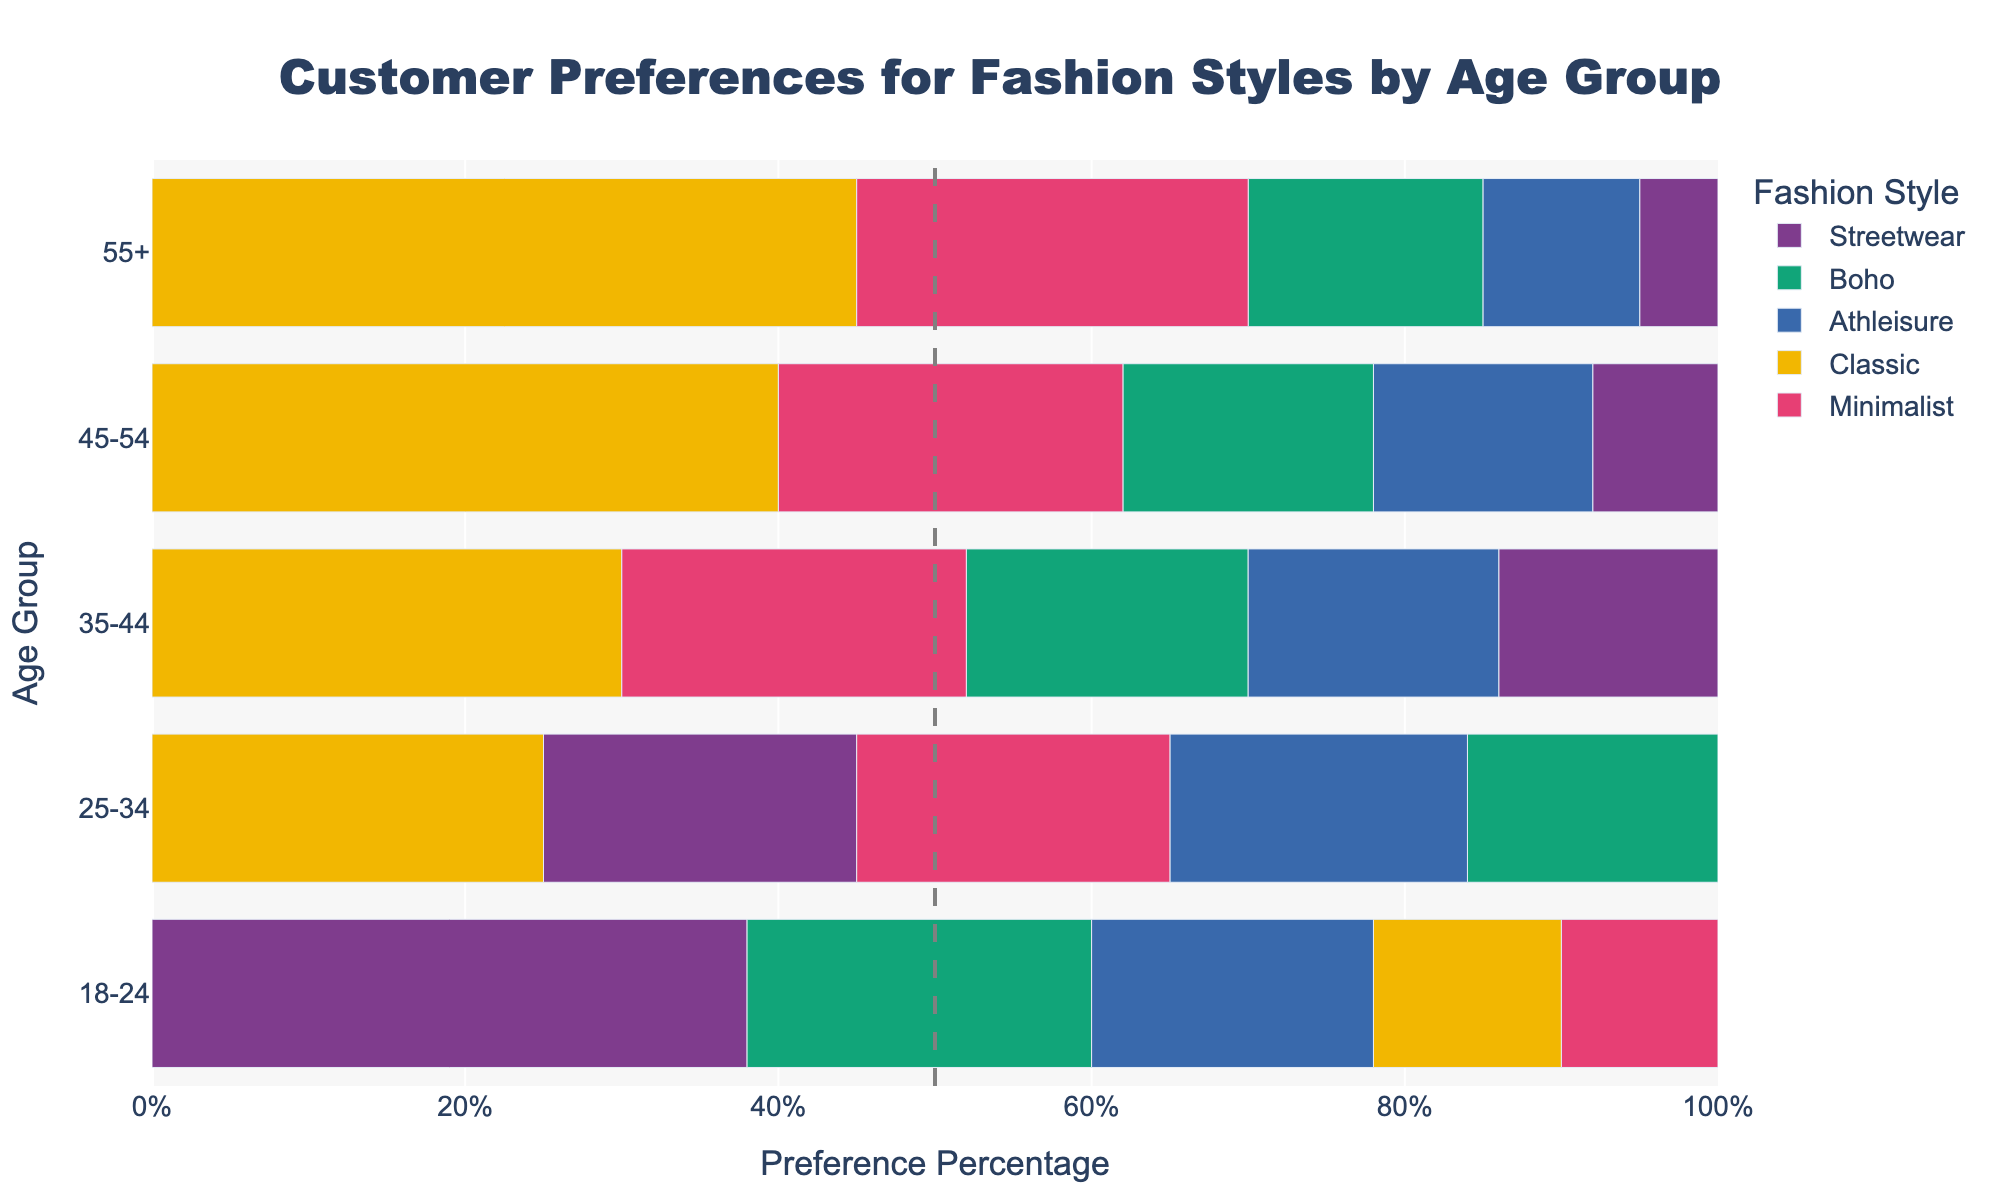Which age group exhibits the highest preference for Classic style? The chart clearly shows that the bar representing the Classic style is longest for the 55+ age group, indicating their strong preference.
Answer: 55+ How does the preference for Streetwear differ between the 18-24 age group and the 55+ age group? By comparing the length of the bars for Streetwear in both age groups, it is visible that it is significantly longer for the 18-24 age group. The preference percentage for Streetwear is 38% for the 18-24 group and 5% for the 55+ group.
Answer: 33% higher for 18-24 Which style is the second most preferred by the 25-34 age group? Observing the length of the bars within the 25-34 age group segment, Classic has the highest preference followed by Minimalist, with the next longer bar.
Answer: Minimalist What is the total preference percentage for all styles combined in the 35-44 age group? Adding up the bars for the 35-44 age group: Classic (30%) + Boho (18%) + Athleisure (16%) + Minimalist (22%) + Streetwear (14%) gives the total preference percentage.
Answer: 100% Which two age groups have an equal preference for the Classic style? Comparing the lengths of the Classic style bars across all age groups, it's noted that the lengths for the 25-34 and 35-44 age groups are equal.
Answer: 25-34 and 35-44 What style has the same preference percentage of 22% in both the 18-24 and 45-54 age groups? By matching the bars with equal lengths for both age groups, it is observed that the Minimalist style has a 22% preference in both groups.
Answer: Minimalist How does the total preference for Boho style compare between the 18-24 and 55+ age groups? Summing the percentage for Boho in both age groups shows 22% for 18-24 and 15% for 55+. Subtracting the values gives the difference.
Answer: 7% higher for 18-24 Which style shows a significant decrease in popularity as age groups increase from 18-24 to 55+? By comparing the lengths of all bars for all styles across different age groups, Streetwear clearly shows a significant decrease in preference from 38% at 18-24 to 5% at 55+.
Answer: Streetwear What is the difference between the highest preference percentage and the lowest preference percentage for the 45-54 age group? Within the 45-54 age group, Classic has the highest preference (40%) and Streetwear has the lowest (8%). Subtracting the two values gives the difference.
Answer: 32% 